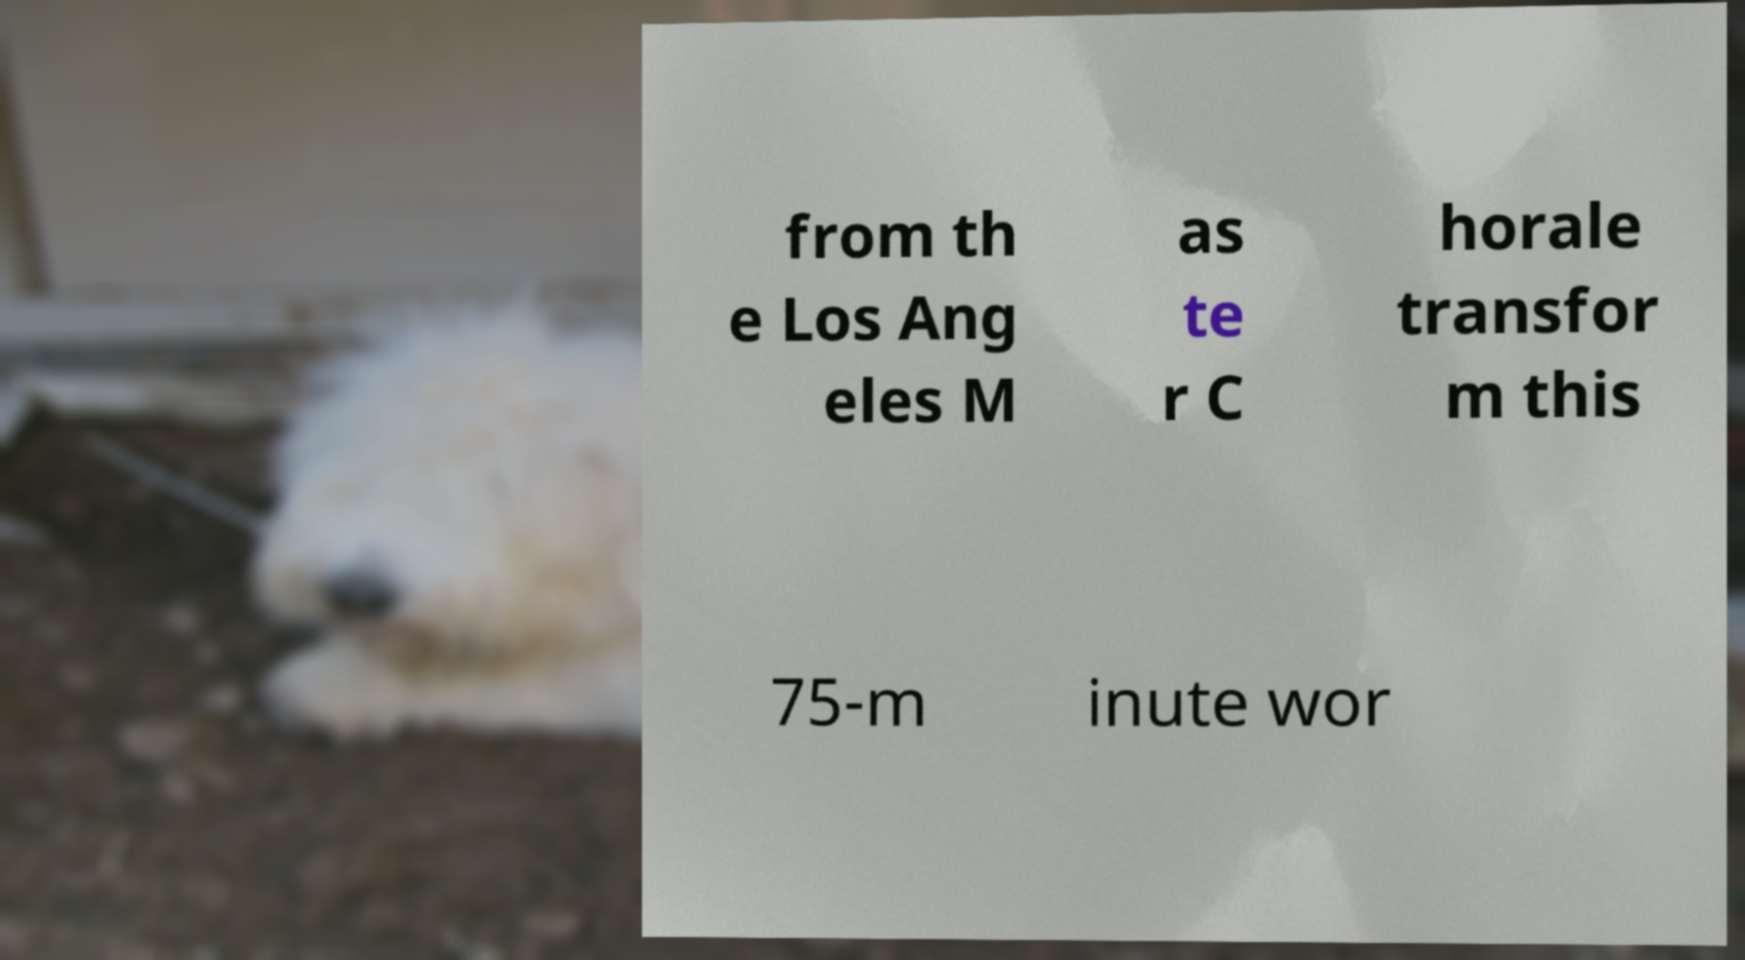Please identify and transcribe the text found in this image. from th e Los Ang eles M as te r C horale transfor m this 75-m inute wor 